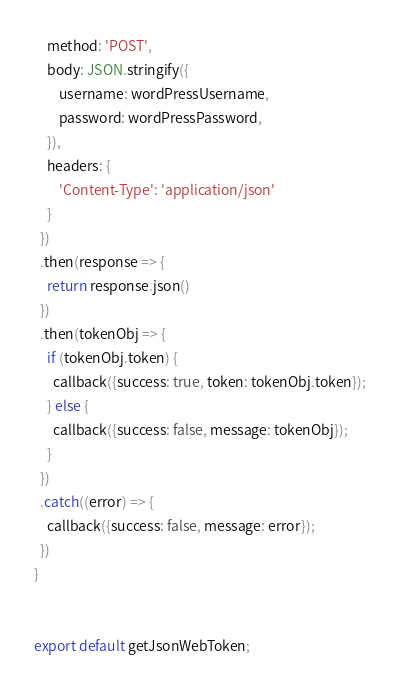<code> <loc_0><loc_0><loc_500><loc_500><_JavaScript_>    method: 'POST',
    body: JSON.stringify({
        username: wordPressUsername,
        password: wordPressPassword,
    }),
    headers: {
        'Content-Type': 'application/json'
    }
  })
  .then(response => {
    return response.json()
  })
  .then(tokenObj => {
    if (tokenObj.token) {
      callback({success: true, token: tokenObj.token});
    } else {
      callback({success: false, message: tokenObj});
    }
  })
  .catch((error) => {
    callback({success: false, message: error});
  })
}


export default getJsonWebToken;
</code> 